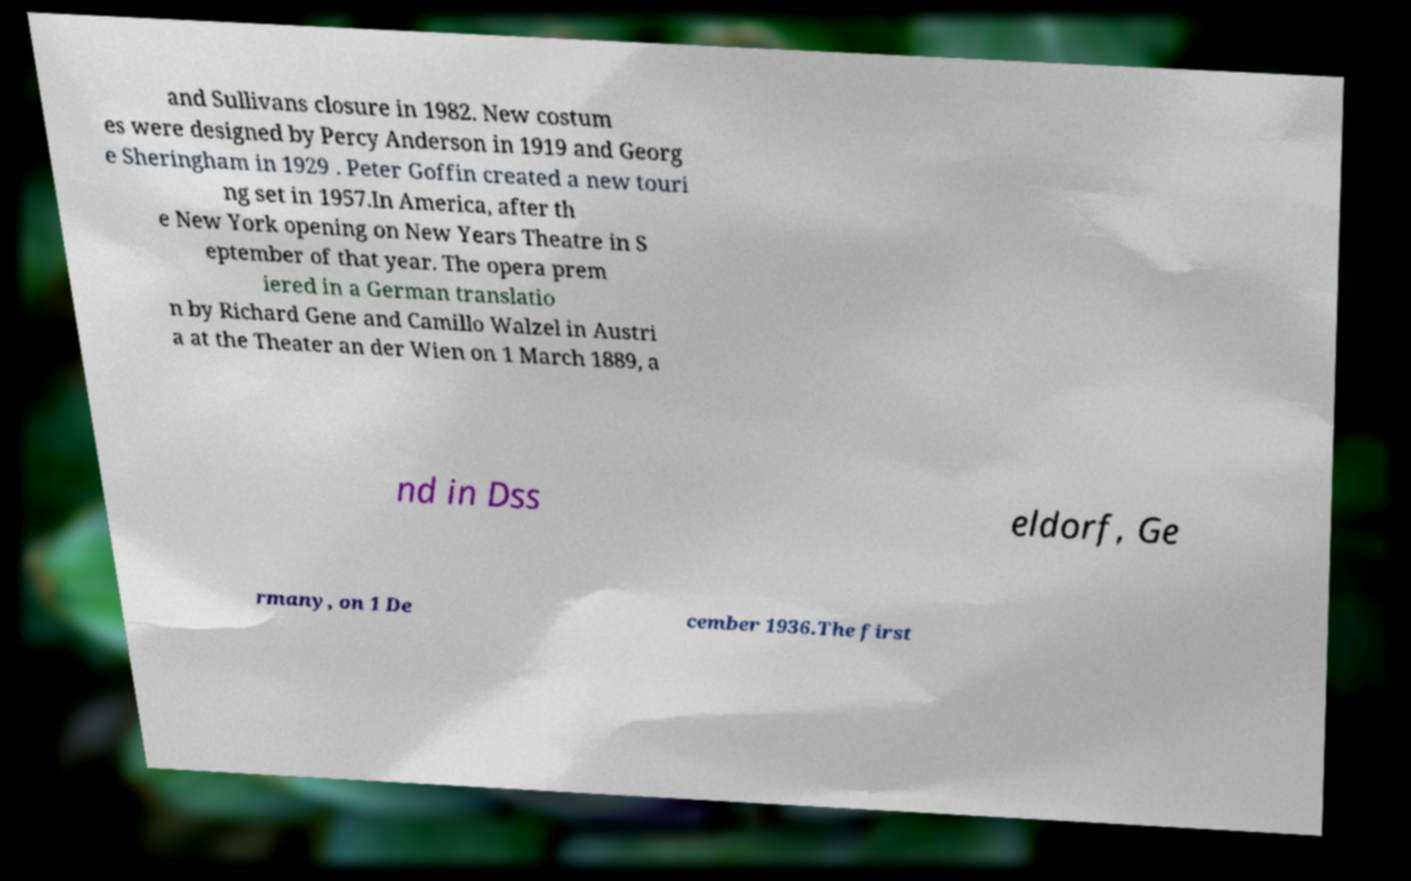Could you extract and type out the text from this image? and Sullivans closure in 1982. New costum es were designed by Percy Anderson in 1919 and Georg e Sheringham in 1929 . Peter Goffin created a new touri ng set in 1957.In America, after th e New York opening on New Years Theatre in S eptember of that year. The opera prem iered in a German translatio n by Richard Gene and Camillo Walzel in Austri a at the Theater an der Wien on 1 March 1889, a nd in Dss eldorf, Ge rmany, on 1 De cember 1936.The first 